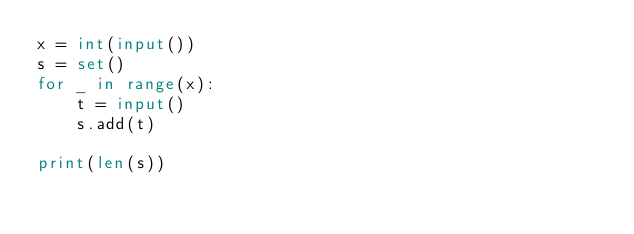<code> <loc_0><loc_0><loc_500><loc_500><_Python_>x = int(input())
s = set()
for _ in range(x):
    t = input()
    s.add(t)

print(len(s))
</code> 